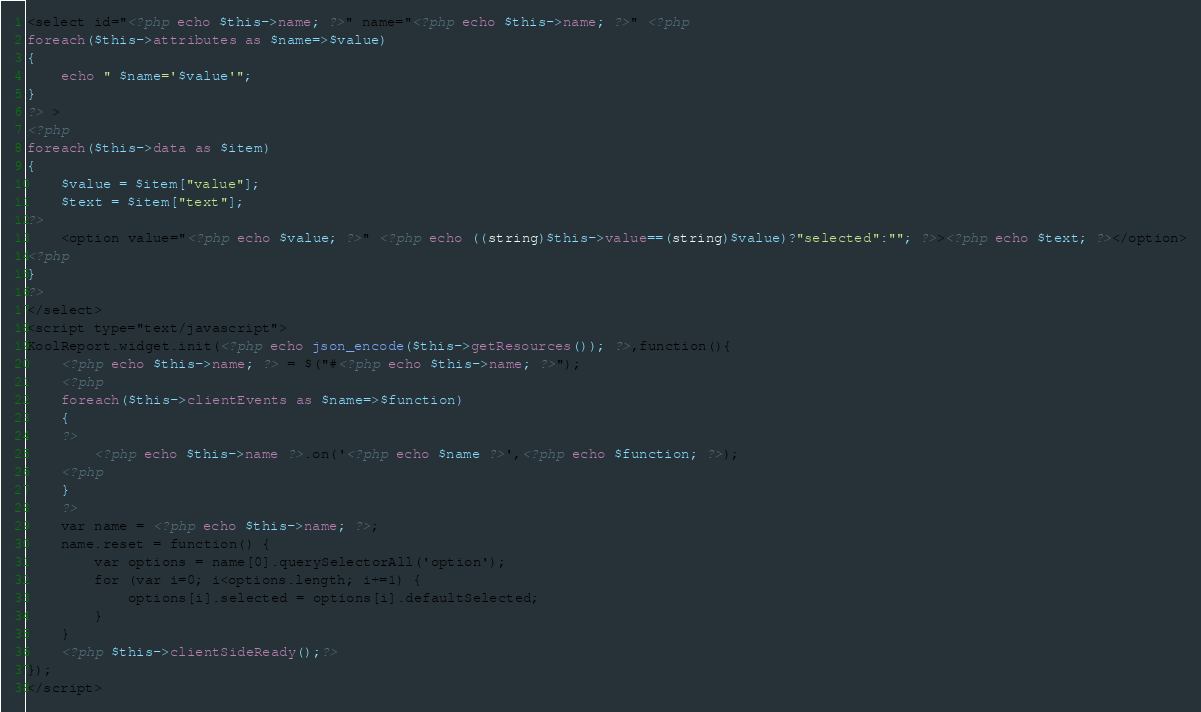<code> <loc_0><loc_0><loc_500><loc_500><_PHP_><select id="<?php echo $this->name; ?>" name="<?php echo $this->name; ?>" <?php
foreach($this->attributes as $name=>$value)
{
    echo " $name='$value'";
}
?> >
<?php
foreach($this->data as $item)
{
    $value = $item["value"];
    $text = $item["text"];
?>
    <option value="<?php echo $value; ?>" <?php echo ((string)$this->value==(string)$value)?"selected":""; ?>><?php echo $text; ?></option>
<?php
}
?>
</select>
<script type="text/javascript">
KoolReport.widget.init(<?php echo json_encode($this->getResources()); ?>,function(){
    <?php echo $this->name; ?> = $("#<?php echo $this->name; ?>");
    <?php
    foreach($this->clientEvents as $name=>$function)
    {
    ?>
        <?php echo $this->name ?>.on('<?php echo $name ?>',<?php echo $function; ?>);
    <?php
    }
    ?>
    var name = <?php echo $this->name; ?>;
    name.reset = function() {
        var options = name[0].querySelectorAll('option');
        for (var i=0; i<options.length; i+=1) {
            options[i].selected = options[i].defaultSelected;
        }
    }
    <?php $this->clientSideReady();?>
});
</script></code> 